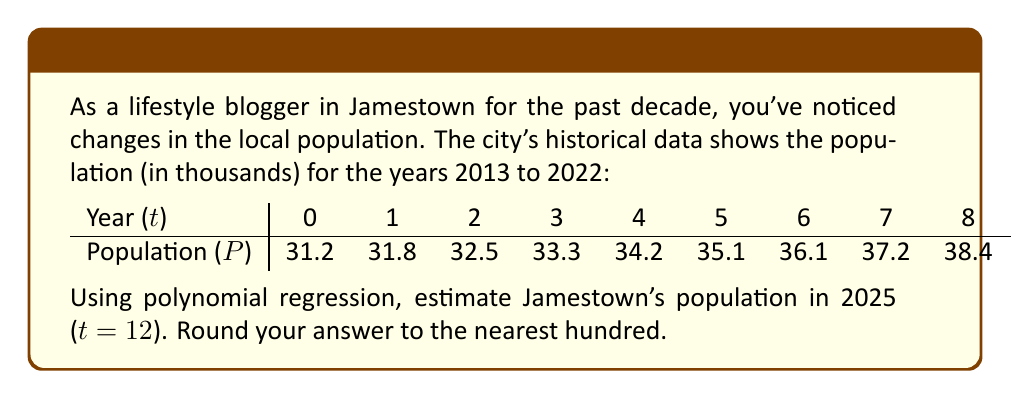Show me your answer to this math problem. To estimate Jamestown's population growth using polynomial regression, we'll use a quadratic model: $P = at^2 + bt + c$

1. First, we need to find the coefficients a, b, and c. We can use a polynomial regression calculator or a spreadsheet for this step. After inputting the data, we get:

   $P = 0.0214t^2 + 0.5086t + 31.24$

2. Now that we have our model, we can estimate the population for 2025. In our time scale, 2025 corresponds to t = 12 (2013 is t = 0).

3. Let's substitute t = 12 into our equation:

   $P = 0.0214(12)^2 + 0.5086(12) + 31.24$

4. Simplify:
   $P = 0.0214(144) + 0.5086(12) + 31.24$
   $P = 3.0816 + 6.1032 + 31.24$
   $P = 40.4248$

5. Remember, P is in thousands, so this represents 40,424.8 people.

6. Rounding to the nearest hundred as requested:

   40,424.8 ≈ 40,400
Answer: 40,400 